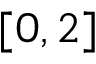<formula> <loc_0><loc_0><loc_500><loc_500>[ 0 , 2 ]</formula> 